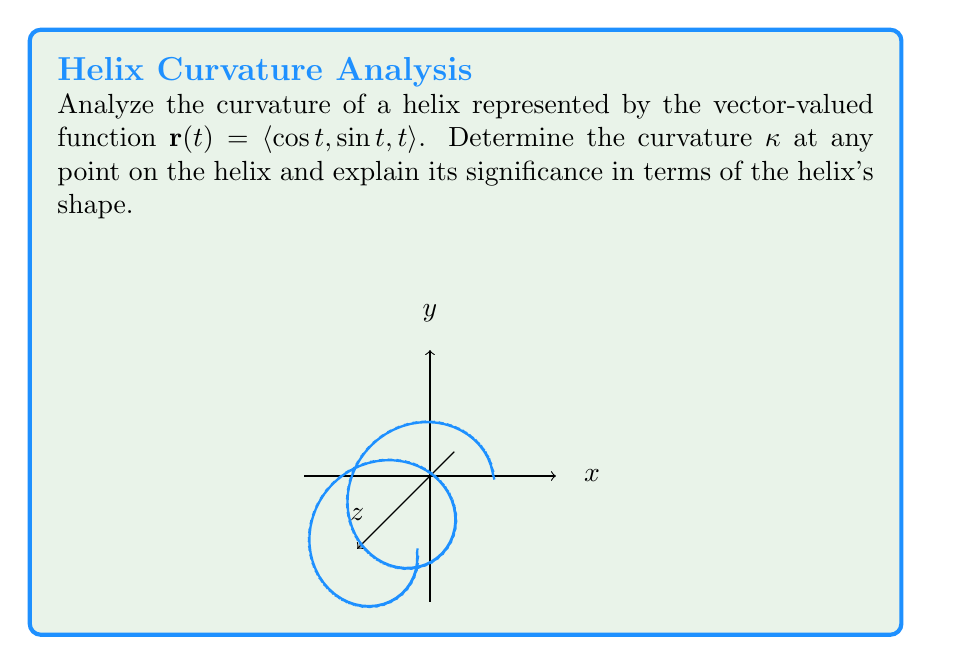Can you answer this question? To analyze the curvature of the helix, we'll follow these steps:

1) First, we need to calculate $\mathbf{r}'(t)$ and $\mathbf{r}''(t)$:

   $\mathbf{r}'(t) = \langle -\sin t, \cos t, 1 \rangle$
   $\mathbf{r}''(t) = \langle -\cos t, -\sin t, 0 \rangle$

2) The curvature formula is given by:

   $\kappa = \frac{|\mathbf{r}'(t) \times \mathbf{r}''(t)|}{|\mathbf{r}'(t)|^3}$

3) Let's calculate the cross product $\mathbf{r}'(t) \times \mathbf{r}''(t)$:

   $\mathbf{r}'(t) \times \mathbf{r}''(t) = \begin{vmatrix} 
   \mathbf{i} & \mathbf{j} & \mathbf{k} \\
   -\sin t & \cos t & 1 \\
   -\cos t & -\sin t & 0
   \end{vmatrix}$

   $= \langle -\sin t, -\cos t, \sin^2 t + \cos^2 t \rangle$
   $= \langle -\sin t, -\cos t, 1 \rangle$

4) The magnitude of this cross product is:

   $|\mathbf{r}'(t) \times \mathbf{r}''(t)| = \sqrt{\sin^2 t + \cos^2 t + 1} = \sqrt{2}$

5) Now, let's calculate $|\mathbf{r}'(t)|$:

   $|\mathbf{r}'(t)| = \sqrt{(-\sin t)^2 + (\cos t)^2 + 1^2} = \sqrt{2}$

6) Substituting into the curvature formula:

   $\kappa = \frac{\sqrt{2}}{(\sqrt{2})^3} = \frac{\sqrt{2}}{2\sqrt{2}} = \frac{1}{2}$

7) The curvature is constant and equal to $\frac{1}{2}$ at every point on the helix.

This constant curvature indicates that the helix maintains a consistent "tightness" as it spirals upward. The value $\frac{1}{2}$ suggests a moderate curvature, neither extremely tight nor very loose. This constant curvature is a characteristic feature of helices and contributes to their uniform, spiral shape in three-dimensional space.
Answer: $\kappa = \frac{1}{2}$ 